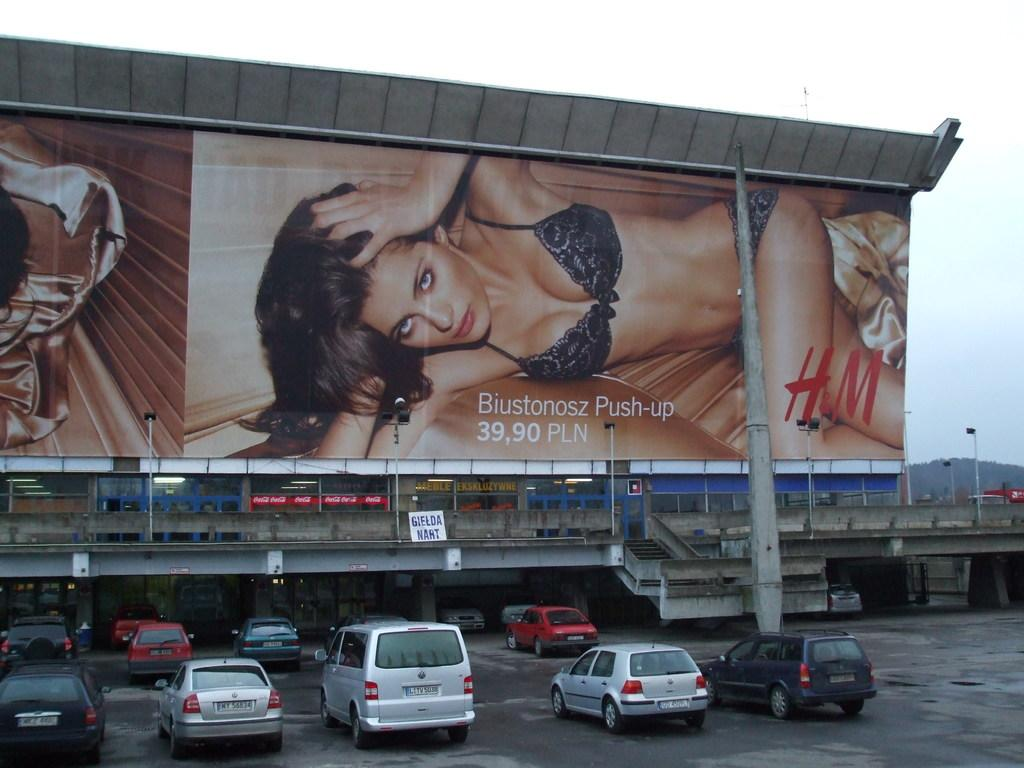<image>
Render a clear and concise summary of the photo. A silver Volkswagon van with plate number LITV5038 sits in front of an HM Banner 